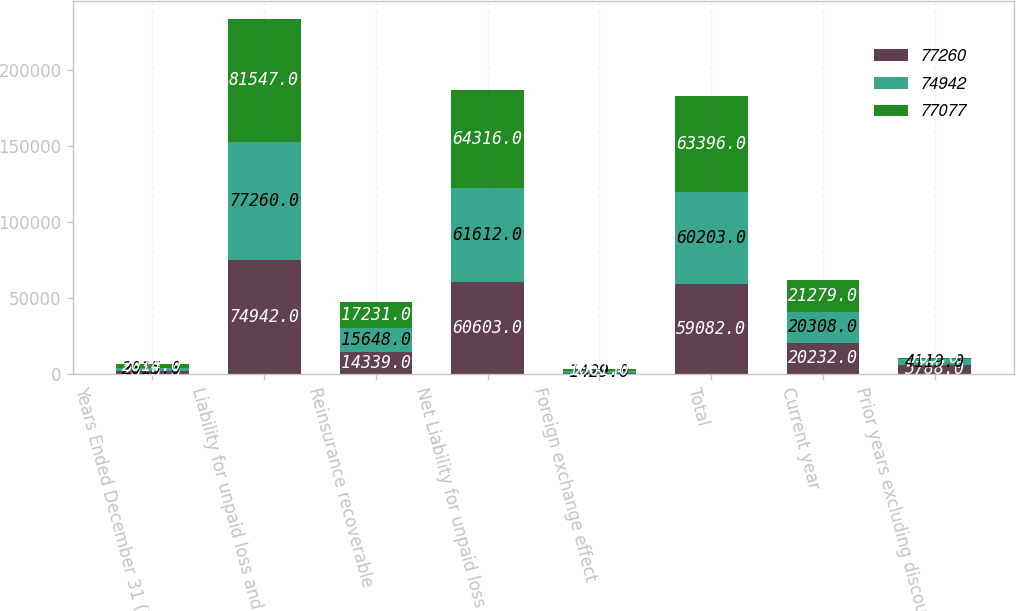Convert chart. <chart><loc_0><loc_0><loc_500><loc_500><stacked_bar_chart><ecel><fcel>Years Ended December 31 (in<fcel>Liability for unpaid loss and<fcel>Reinsurance recoverable<fcel>Net Liability for unpaid loss<fcel>Foreign exchange effect<fcel>Total<fcel>Current year<fcel>Prior years excluding discount<nl><fcel>77260<fcel>2016<fcel>74942<fcel>14339<fcel>60603<fcel>463<fcel>59082<fcel>20232<fcel>5788<nl><fcel>74942<fcel>2015<fcel>77260<fcel>15648<fcel>61612<fcel>1429<fcel>60203<fcel>20308<fcel>4119<nl><fcel>77077<fcel>2014<fcel>81547<fcel>17231<fcel>64316<fcel>1061<fcel>63396<fcel>21279<fcel>703<nl></chart> 